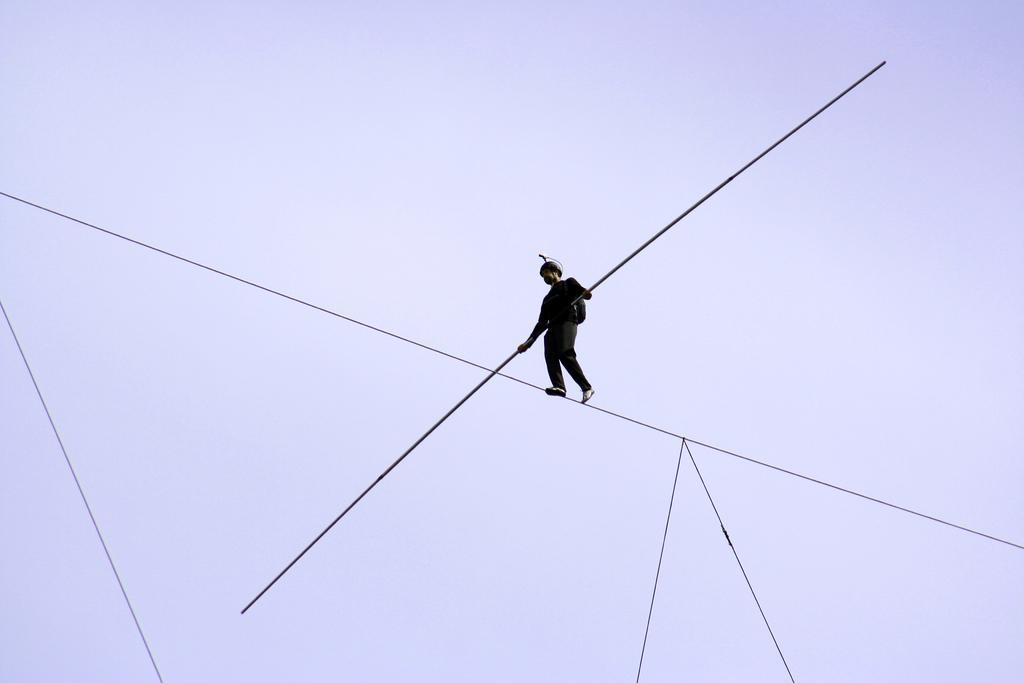In one or two sentences, can you explain what this image depicts? In the background portion of the picture we can see the sky. We can see a person in a black attire, holding a pole in the hands and walking on a rope. In this picture we can see ropes. 